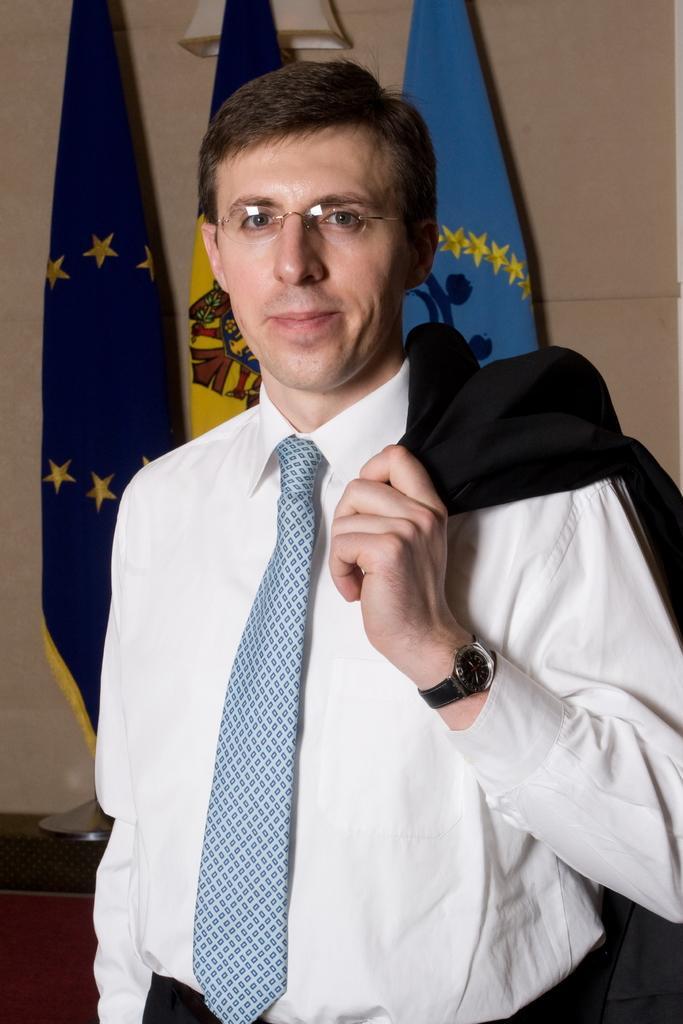How would you summarize this image in a sentence or two? In this image there is a person wearing goggles, behind him there are flags on the table and an object attached to the wall. 